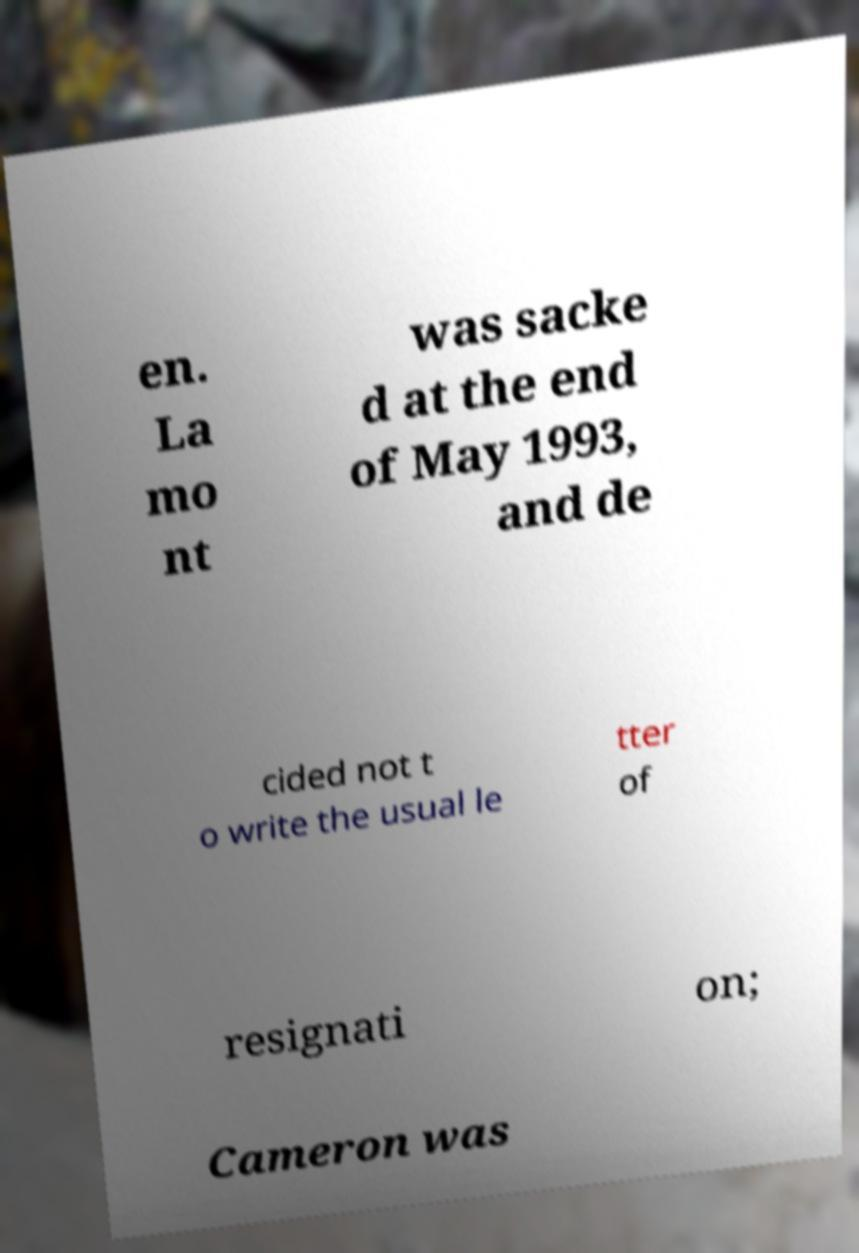Please read and relay the text visible in this image. What does it say? en. La mo nt was sacke d at the end of May 1993, and de cided not t o write the usual le tter of resignati on; Cameron was 